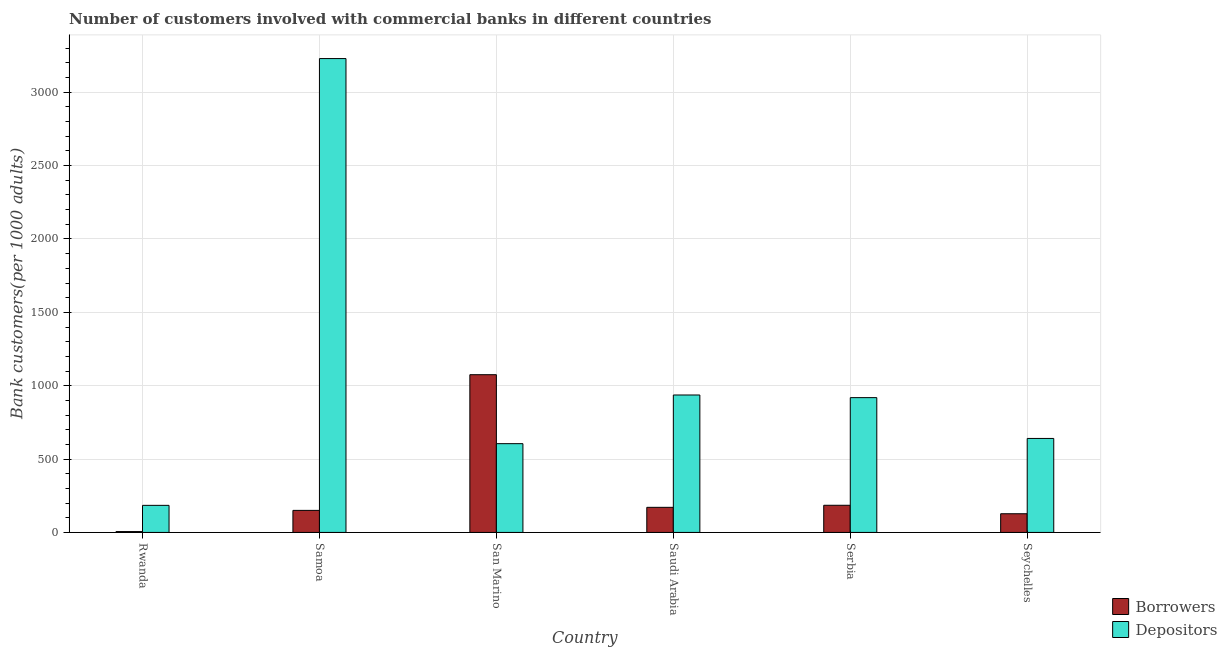How many different coloured bars are there?
Keep it short and to the point. 2. Are the number of bars on each tick of the X-axis equal?
Offer a very short reply. Yes. What is the label of the 1st group of bars from the left?
Keep it short and to the point. Rwanda. What is the number of borrowers in Samoa?
Keep it short and to the point. 150.32. Across all countries, what is the maximum number of depositors?
Make the answer very short. 3229.69. Across all countries, what is the minimum number of depositors?
Your answer should be very brief. 184.58. In which country was the number of borrowers maximum?
Provide a succinct answer. San Marino. In which country was the number of depositors minimum?
Give a very brief answer. Rwanda. What is the total number of depositors in the graph?
Keep it short and to the point. 6515.4. What is the difference between the number of borrowers in San Marino and that in Saudi Arabia?
Your answer should be very brief. 904.02. What is the difference between the number of depositors in Seychelles and the number of borrowers in Saudi Arabia?
Your answer should be compact. 469.51. What is the average number of depositors per country?
Your response must be concise. 1085.9. What is the difference between the number of borrowers and number of depositors in Rwanda?
Your response must be concise. -178.64. In how many countries, is the number of borrowers greater than 200 ?
Give a very brief answer. 1. What is the ratio of the number of depositors in San Marino to that in Serbia?
Ensure brevity in your answer.  0.66. Is the number of depositors in Saudi Arabia less than that in Seychelles?
Keep it short and to the point. No. What is the difference between the highest and the second highest number of borrowers?
Provide a short and direct response. 889.94. What is the difference between the highest and the lowest number of depositors?
Make the answer very short. 3045.11. In how many countries, is the number of depositors greater than the average number of depositors taken over all countries?
Your answer should be very brief. 1. Is the sum of the number of borrowers in Rwanda and Samoa greater than the maximum number of depositors across all countries?
Your response must be concise. No. What does the 2nd bar from the left in Serbia represents?
Give a very brief answer. Depositors. What does the 1st bar from the right in Samoa represents?
Keep it short and to the point. Depositors. Are all the bars in the graph horizontal?
Ensure brevity in your answer.  No. How many countries are there in the graph?
Your answer should be very brief. 6. What is the difference between two consecutive major ticks on the Y-axis?
Your response must be concise. 500. Are the values on the major ticks of Y-axis written in scientific E-notation?
Give a very brief answer. No. Does the graph contain grids?
Keep it short and to the point. Yes. What is the title of the graph?
Make the answer very short. Number of customers involved with commercial banks in different countries. What is the label or title of the X-axis?
Ensure brevity in your answer.  Country. What is the label or title of the Y-axis?
Offer a very short reply. Bank customers(per 1000 adults). What is the Bank customers(per 1000 adults) of Borrowers in Rwanda?
Offer a terse response. 5.94. What is the Bank customers(per 1000 adults) of Depositors in Rwanda?
Your answer should be very brief. 184.58. What is the Bank customers(per 1000 adults) of Borrowers in Samoa?
Ensure brevity in your answer.  150.32. What is the Bank customers(per 1000 adults) of Depositors in Samoa?
Your answer should be compact. 3229.69. What is the Bank customers(per 1000 adults) in Borrowers in San Marino?
Offer a terse response. 1075.09. What is the Bank customers(per 1000 adults) of Depositors in San Marino?
Give a very brief answer. 605.04. What is the Bank customers(per 1000 adults) in Borrowers in Saudi Arabia?
Provide a succinct answer. 171.07. What is the Bank customers(per 1000 adults) in Depositors in Saudi Arabia?
Provide a succinct answer. 936.72. What is the Bank customers(per 1000 adults) in Borrowers in Serbia?
Make the answer very short. 185.15. What is the Bank customers(per 1000 adults) in Depositors in Serbia?
Your response must be concise. 918.79. What is the Bank customers(per 1000 adults) of Borrowers in Seychelles?
Give a very brief answer. 127.43. What is the Bank customers(per 1000 adults) of Depositors in Seychelles?
Your answer should be very brief. 640.58. Across all countries, what is the maximum Bank customers(per 1000 adults) in Borrowers?
Make the answer very short. 1075.09. Across all countries, what is the maximum Bank customers(per 1000 adults) of Depositors?
Ensure brevity in your answer.  3229.69. Across all countries, what is the minimum Bank customers(per 1000 adults) of Borrowers?
Make the answer very short. 5.94. Across all countries, what is the minimum Bank customers(per 1000 adults) in Depositors?
Your answer should be very brief. 184.58. What is the total Bank customers(per 1000 adults) of Borrowers in the graph?
Offer a very short reply. 1715. What is the total Bank customers(per 1000 adults) of Depositors in the graph?
Make the answer very short. 6515.4. What is the difference between the Bank customers(per 1000 adults) of Borrowers in Rwanda and that in Samoa?
Provide a succinct answer. -144.38. What is the difference between the Bank customers(per 1000 adults) of Depositors in Rwanda and that in Samoa?
Your answer should be very brief. -3045.11. What is the difference between the Bank customers(per 1000 adults) in Borrowers in Rwanda and that in San Marino?
Offer a very short reply. -1069.15. What is the difference between the Bank customers(per 1000 adults) in Depositors in Rwanda and that in San Marino?
Keep it short and to the point. -420.46. What is the difference between the Bank customers(per 1000 adults) in Borrowers in Rwanda and that in Saudi Arabia?
Your response must be concise. -165.12. What is the difference between the Bank customers(per 1000 adults) in Depositors in Rwanda and that in Saudi Arabia?
Make the answer very short. -752.14. What is the difference between the Bank customers(per 1000 adults) of Borrowers in Rwanda and that in Serbia?
Make the answer very short. -179.21. What is the difference between the Bank customers(per 1000 adults) of Depositors in Rwanda and that in Serbia?
Keep it short and to the point. -734.21. What is the difference between the Bank customers(per 1000 adults) in Borrowers in Rwanda and that in Seychelles?
Give a very brief answer. -121.48. What is the difference between the Bank customers(per 1000 adults) in Depositors in Rwanda and that in Seychelles?
Your response must be concise. -456. What is the difference between the Bank customers(per 1000 adults) of Borrowers in Samoa and that in San Marino?
Offer a very short reply. -924.77. What is the difference between the Bank customers(per 1000 adults) of Depositors in Samoa and that in San Marino?
Provide a succinct answer. 2624.65. What is the difference between the Bank customers(per 1000 adults) in Borrowers in Samoa and that in Saudi Arabia?
Make the answer very short. -20.74. What is the difference between the Bank customers(per 1000 adults) in Depositors in Samoa and that in Saudi Arabia?
Your answer should be compact. 2292.98. What is the difference between the Bank customers(per 1000 adults) in Borrowers in Samoa and that in Serbia?
Provide a short and direct response. -34.83. What is the difference between the Bank customers(per 1000 adults) of Depositors in Samoa and that in Serbia?
Keep it short and to the point. 2310.9. What is the difference between the Bank customers(per 1000 adults) in Borrowers in Samoa and that in Seychelles?
Keep it short and to the point. 22.9. What is the difference between the Bank customers(per 1000 adults) in Depositors in Samoa and that in Seychelles?
Your answer should be compact. 2589.11. What is the difference between the Bank customers(per 1000 adults) of Borrowers in San Marino and that in Saudi Arabia?
Ensure brevity in your answer.  904.02. What is the difference between the Bank customers(per 1000 adults) in Depositors in San Marino and that in Saudi Arabia?
Your response must be concise. -331.67. What is the difference between the Bank customers(per 1000 adults) in Borrowers in San Marino and that in Serbia?
Your answer should be very brief. 889.94. What is the difference between the Bank customers(per 1000 adults) of Depositors in San Marino and that in Serbia?
Your answer should be compact. -313.75. What is the difference between the Bank customers(per 1000 adults) in Borrowers in San Marino and that in Seychelles?
Make the answer very short. 947.66. What is the difference between the Bank customers(per 1000 adults) of Depositors in San Marino and that in Seychelles?
Give a very brief answer. -35.54. What is the difference between the Bank customers(per 1000 adults) in Borrowers in Saudi Arabia and that in Serbia?
Provide a succinct answer. -14.09. What is the difference between the Bank customers(per 1000 adults) in Depositors in Saudi Arabia and that in Serbia?
Offer a very short reply. 17.93. What is the difference between the Bank customers(per 1000 adults) of Borrowers in Saudi Arabia and that in Seychelles?
Offer a terse response. 43.64. What is the difference between the Bank customers(per 1000 adults) in Depositors in Saudi Arabia and that in Seychelles?
Your response must be concise. 296.14. What is the difference between the Bank customers(per 1000 adults) in Borrowers in Serbia and that in Seychelles?
Your response must be concise. 57.73. What is the difference between the Bank customers(per 1000 adults) of Depositors in Serbia and that in Seychelles?
Make the answer very short. 278.21. What is the difference between the Bank customers(per 1000 adults) in Borrowers in Rwanda and the Bank customers(per 1000 adults) in Depositors in Samoa?
Make the answer very short. -3223.75. What is the difference between the Bank customers(per 1000 adults) in Borrowers in Rwanda and the Bank customers(per 1000 adults) in Depositors in San Marino?
Offer a very short reply. -599.1. What is the difference between the Bank customers(per 1000 adults) in Borrowers in Rwanda and the Bank customers(per 1000 adults) in Depositors in Saudi Arabia?
Your answer should be compact. -930.77. What is the difference between the Bank customers(per 1000 adults) of Borrowers in Rwanda and the Bank customers(per 1000 adults) of Depositors in Serbia?
Provide a short and direct response. -912.85. What is the difference between the Bank customers(per 1000 adults) of Borrowers in Rwanda and the Bank customers(per 1000 adults) of Depositors in Seychelles?
Keep it short and to the point. -634.64. What is the difference between the Bank customers(per 1000 adults) of Borrowers in Samoa and the Bank customers(per 1000 adults) of Depositors in San Marino?
Your answer should be very brief. -454.72. What is the difference between the Bank customers(per 1000 adults) of Borrowers in Samoa and the Bank customers(per 1000 adults) of Depositors in Saudi Arabia?
Ensure brevity in your answer.  -786.39. What is the difference between the Bank customers(per 1000 adults) of Borrowers in Samoa and the Bank customers(per 1000 adults) of Depositors in Serbia?
Ensure brevity in your answer.  -768.47. What is the difference between the Bank customers(per 1000 adults) in Borrowers in Samoa and the Bank customers(per 1000 adults) in Depositors in Seychelles?
Provide a succinct answer. -490.26. What is the difference between the Bank customers(per 1000 adults) of Borrowers in San Marino and the Bank customers(per 1000 adults) of Depositors in Saudi Arabia?
Offer a very short reply. 138.37. What is the difference between the Bank customers(per 1000 adults) in Borrowers in San Marino and the Bank customers(per 1000 adults) in Depositors in Serbia?
Offer a terse response. 156.3. What is the difference between the Bank customers(per 1000 adults) of Borrowers in San Marino and the Bank customers(per 1000 adults) of Depositors in Seychelles?
Provide a short and direct response. 434.51. What is the difference between the Bank customers(per 1000 adults) in Borrowers in Saudi Arabia and the Bank customers(per 1000 adults) in Depositors in Serbia?
Your response must be concise. -747.72. What is the difference between the Bank customers(per 1000 adults) in Borrowers in Saudi Arabia and the Bank customers(per 1000 adults) in Depositors in Seychelles?
Ensure brevity in your answer.  -469.51. What is the difference between the Bank customers(per 1000 adults) of Borrowers in Serbia and the Bank customers(per 1000 adults) of Depositors in Seychelles?
Offer a very short reply. -455.43. What is the average Bank customers(per 1000 adults) in Borrowers per country?
Provide a short and direct response. 285.83. What is the average Bank customers(per 1000 adults) in Depositors per country?
Provide a short and direct response. 1085.9. What is the difference between the Bank customers(per 1000 adults) in Borrowers and Bank customers(per 1000 adults) in Depositors in Rwanda?
Your answer should be compact. -178.64. What is the difference between the Bank customers(per 1000 adults) in Borrowers and Bank customers(per 1000 adults) in Depositors in Samoa?
Give a very brief answer. -3079.37. What is the difference between the Bank customers(per 1000 adults) in Borrowers and Bank customers(per 1000 adults) in Depositors in San Marino?
Give a very brief answer. 470.05. What is the difference between the Bank customers(per 1000 adults) in Borrowers and Bank customers(per 1000 adults) in Depositors in Saudi Arabia?
Your answer should be compact. -765.65. What is the difference between the Bank customers(per 1000 adults) in Borrowers and Bank customers(per 1000 adults) in Depositors in Serbia?
Ensure brevity in your answer.  -733.64. What is the difference between the Bank customers(per 1000 adults) in Borrowers and Bank customers(per 1000 adults) in Depositors in Seychelles?
Your response must be concise. -513.15. What is the ratio of the Bank customers(per 1000 adults) of Borrowers in Rwanda to that in Samoa?
Make the answer very short. 0.04. What is the ratio of the Bank customers(per 1000 adults) of Depositors in Rwanda to that in Samoa?
Your response must be concise. 0.06. What is the ratio of the Bank customers(per 1000 adults) in Borrowers in Rwanda to that in San Marino?
Ensure brevity in your answer.  0.01. What is the ratio of the Bank customers(per 1000 adults) in Depositors in Rwanda to that in San Marino?
Your response must be concise. 0.31. What is the ratio of the Bank customers(per 1000 adults) in Borrowers in Rwanda to that in Saudi Arabia?
Offer a terse response. 0.03. What is the ratio of the Bank customers(per 1000 adults) in Depositors in Rwanda to that in Saudi Arabia?
Provide a succinct answer. 0.2. What is the ratio of the Bank customers(per 1000 adults) in Borrowers in Rwanda to that in Serbia?
Provide a succinct answer. 0.03. What is the ratio of the Bank customers(per 1000 adults) of Depositors in Rwanda to that in Serbia?
Give a very brief answer. 0.2. What is the ratio of the Bank customers(per 1000 adults) in Borrowers in Rwanda to that in Seychelles?
Keep it short and to the point. 0.05. What is the ratio of the Bank customers(per 1000 adults) of Depositors in Rwanda to that in Seychelles?
Provide a short and direct response. 0.29. What is the ratio of the Bank customers(per 1000 adults) of Borrowers in Samoa to that in San Marino?
Keep it short and to the point. 0.14. What is the ratio of the Bank customers(per 1000 adults) of Depositors in Samoa to that in San Marino?
Ensure brevity in your answer.  5.34. What is the ratio of the Bank customers(per 1000 adults) of Borrowers in Samoa to that in Saudi Arabia?
Your answer should be very brief. 0.88. What is the ratio of the Bank customers(per 1000 adults) in Depositors in Samoa to that in Saudi Arabia?
Ensure brevity in your answer.  3.45. What is the ratio of the Bank customers(per 1000 adults) of Borrowers in Samoa to that in Serbia?
Offer a very short reply. 0.81. What is the ratio of the Bank customers(per 1000 adults) of Depositors in Samoa to that in Serbia?
Keep it short and to the point. 3.52. What is the ratio of the Bank customers(per 1000 adults) in Borrowers in Samoa to that in Seychelles?
Provide a short and direct response. 1.18. What is the ratio of the Bank customers(per 1000 adults) of Depositors in Samoa to that in Seychelles?
Make the answer very short. 5.04. What is the ratio of the Bank customers(per 1000 adults) in Borrowers in San Marino to that in Saudi Arabia?
Ensure brevity in your answer.  6.28. What is the ratio of the Bank customers(per 1000 adults) of Depositors in San Marino to that in Saudi Arabia?
Your answer should be compact. 0.65. What is the ratio of the Bank customers(per 1000 adults) of Borrowers in San Marino to that in Serbia?
Your answer should be compact. 5.81. What is the ratio of the Bank customers(per 1000 adults) of Depositors in San Marino to that in Serbia?
Keep it short and to the point. 0.66. What is the ratio of the Bank customers(per 1000 adults) of Borrowers in San Marino to that in Seychelles?
Your response must be concise. 8.44. What is the ratio of the Bank customers(per 1000 adults) in Depositors in San Marino to that in Seychelles?
Offer a very short reply. 0.94. What is the ratio of the Bank customers(per 1000 adults) in Borrowers in Saudi Arabia to that in Serbia?
Provide a succinct answer. 0.92. What is the ratio of the Bank customers(per 1000 adults) of Depositors in Saudi Arabia to that in Serbia?
Ensure brevity in your answer.  1.02. What is the ratio of the Bank customers(per 1000 adults) in Borrowers in Saudi Arabia to that in Seychelles?
Your answer should be very brief. 1.34. What is the ratio of the Bank customers(per 1000 adults) of Depositors in Saudi Arabia to that in Seychelles?
Offer a very short reply. 1.46. What is the ratio of the Bank customers(per 1000 adults) in Borrowers in Serbia to that in Seychelles?
Your answer should be compact. 1.45. What is the ratio of the Bank customers(per 1000 adults) in Depositors in Serbia to that in Seychelles?
Ensure brevity in your answer.  1.43. What is the difference between the highest and the second highest Bank customers(per 1000 adults) in Borrowers?
Offer a very short reply. 889.94. What is the difference between the highest and the second highest Bank customers(per 1000 adults) in Depositors?
Provide a short and direct response. 2292.98. What is the difference between the highest and the lowest Bank customers(per 1000 adults) in Borrowers?
Keep it short and to the point. 1069.15. What is the difference between the highest and the lowest Bank customers(per 1000 adults) in Depositors?
Your response must be concise. 3045.11. 